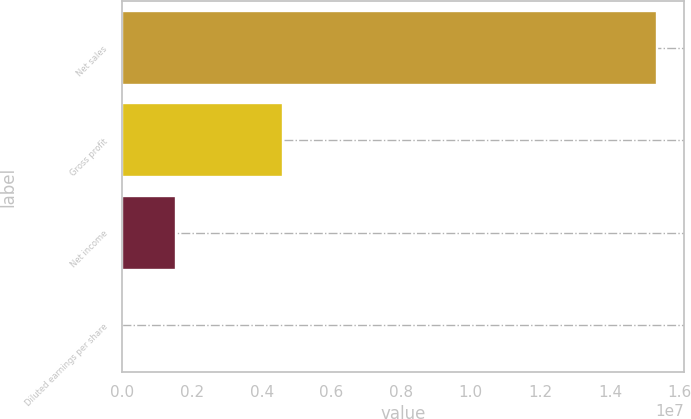<chart> <loc_0><loc_0><loc_500><loc_500><bar_chart><fcel>Net sales<fcel>Gross profit<fcel>Net income<fcel>Diluted earnings per share<nl><fcel>1.53416e+07<fcel>4.59376e+06<fcel>1.53417e+06<fcel>4.61<nl></chart> 